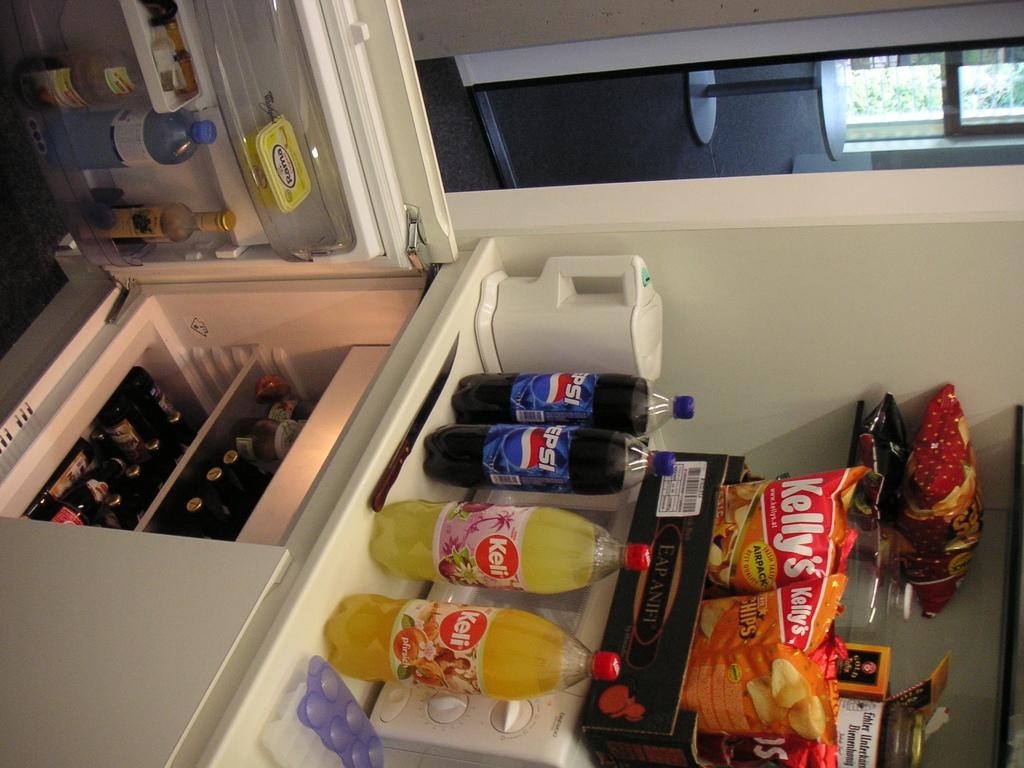<image>
Relay a brief, clear account of the picture shown. Kelly's brand chips are arranged on a microwave, while Keli brand soda and Pepsi brand soda are arranged above a fridge 